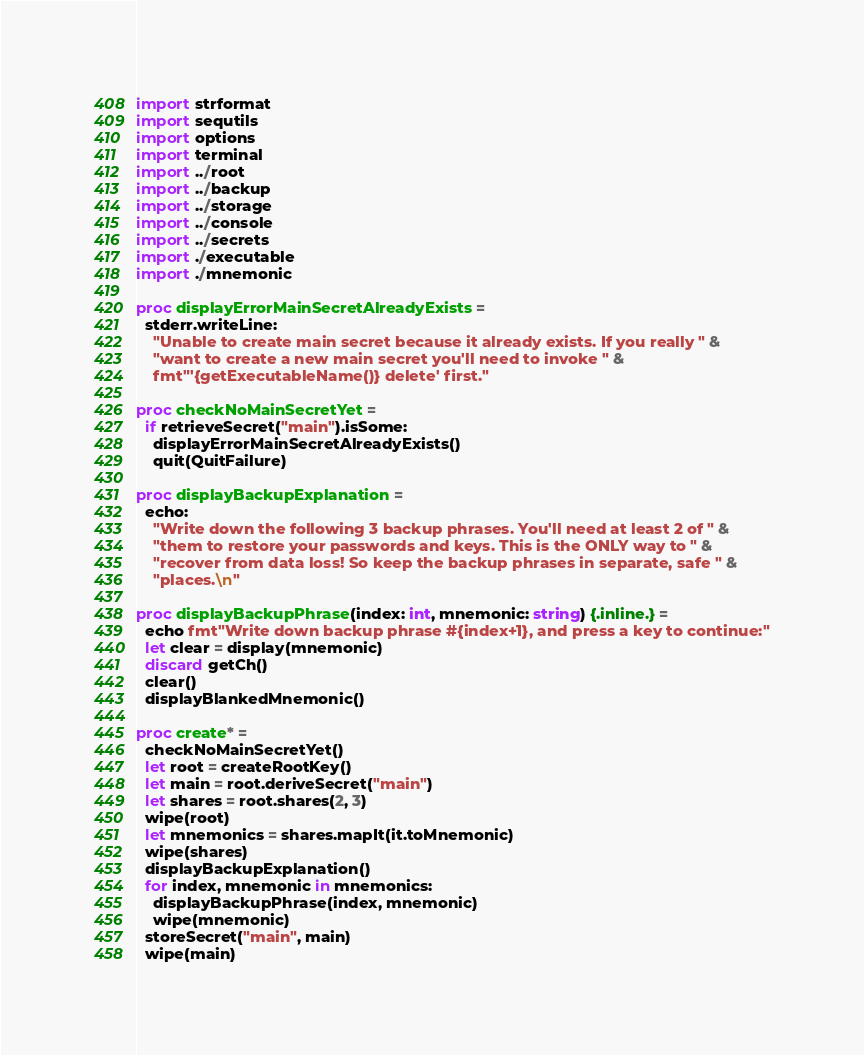Convert code to text. <code><loc_0><loc_0><loc_500><loc_500><_Nim_>import strformat
import sequtils
import options
import terminal
import ../root
import ../backup
import ../storage
import ../console
import ../secrets
import ./executable
import ./mnemonic

proc displayErrorMainSecretAlreadyExists =
  stderr.writeLine:
    "Unable to create main secret because it already exists. If you really " &
    "want to create a new main secret you'll need to invoke " &
    fmt"'{getExecutableName()} delete' first."

proc checkNoMainSecretYet =
  if retrieveSecret("main").isSome:
    displayErrorMainSecretAlreadyExists()
    quit(QuitFailure)

proc displayBackupExplanation =
  echo:
    "Write down the following 3 backup phrases. You'll need at least 2 of " &
    "them to restore your passwords and keys. This is the ONLY way to " &
    "recover from data loss! So keep the backup phrases in separate, safe " &
    "places.\n"

proc displayBackupPhrase(index: int, mnemonic: string) {.inline.} =
  echo fmt"Write down backup phrase #{index+1}, and press a key to continue:"
  let clear = display(mnemonic)
  discard getCh()
  clear()
  displayBlankedMnemonic()

proc create* =
  checkNoMainSecretYet()
  let root = createRootKey()
  let main = root.deriveSecret("main")
  let shares = root.shares(2, 3)
  wipe(root)
  let mnemonics = shares.mapIt(it.toMnemonic)
  wipe(shares)
  displayBackupExplanation()
  for index, mnemonic in mnemonics:
    displayBackupPhrase(index, mnemonic)
    wipe(mnemonic)
  storeSecret("main", main)
  wipe(main)
</code> 